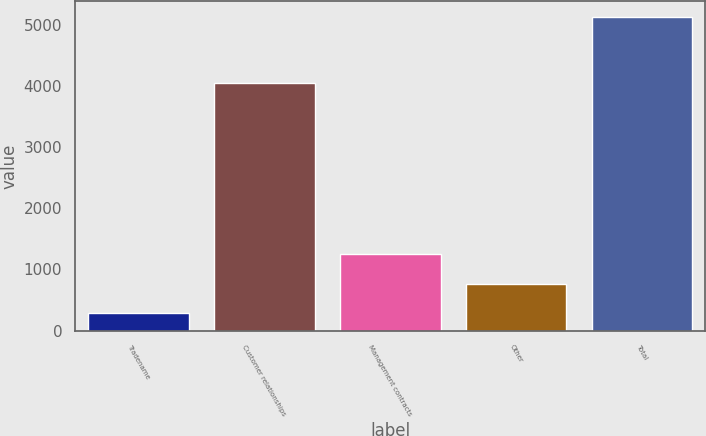Convert chart. <chart><loc_0><loc_0><loc_500><loc_500><bar_chart><fcel>Tradename<fcel>Customer relationships<fcel>Management contracts<fcel>Other<fcel>Total<nl><fcel>283<fcel>4059<fcel>1254.2<fcel>768.6<fcel>5139<nl></chart> 